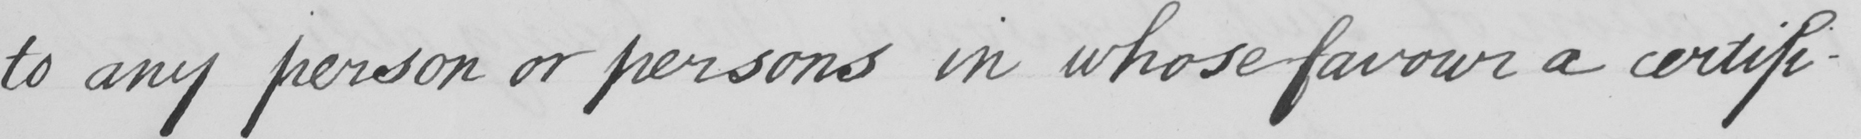What does this handwritten line say? to any person or persons in whose favour a certifi- 